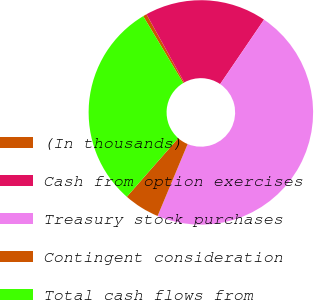Convert chart to OTSL. <chart><loc_0><loc_0><loc_500><loc_500><pie_chart><fcel>(In thousands)<fcel>Cash from option exercises<fcel>Treasury stock purchases<fcel>Contingent consideration<fcel>Total cash flows from<nl><fcel>0.54%<fcel>17.57%<fcel>46.78%<fcel>5.17%<fcel>29.94%<nl></chart> 